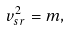<formula> <loc_0><loc_0><loc_500><loc_500>v _ { s r } ^ { 2 } = m ,</formula> 